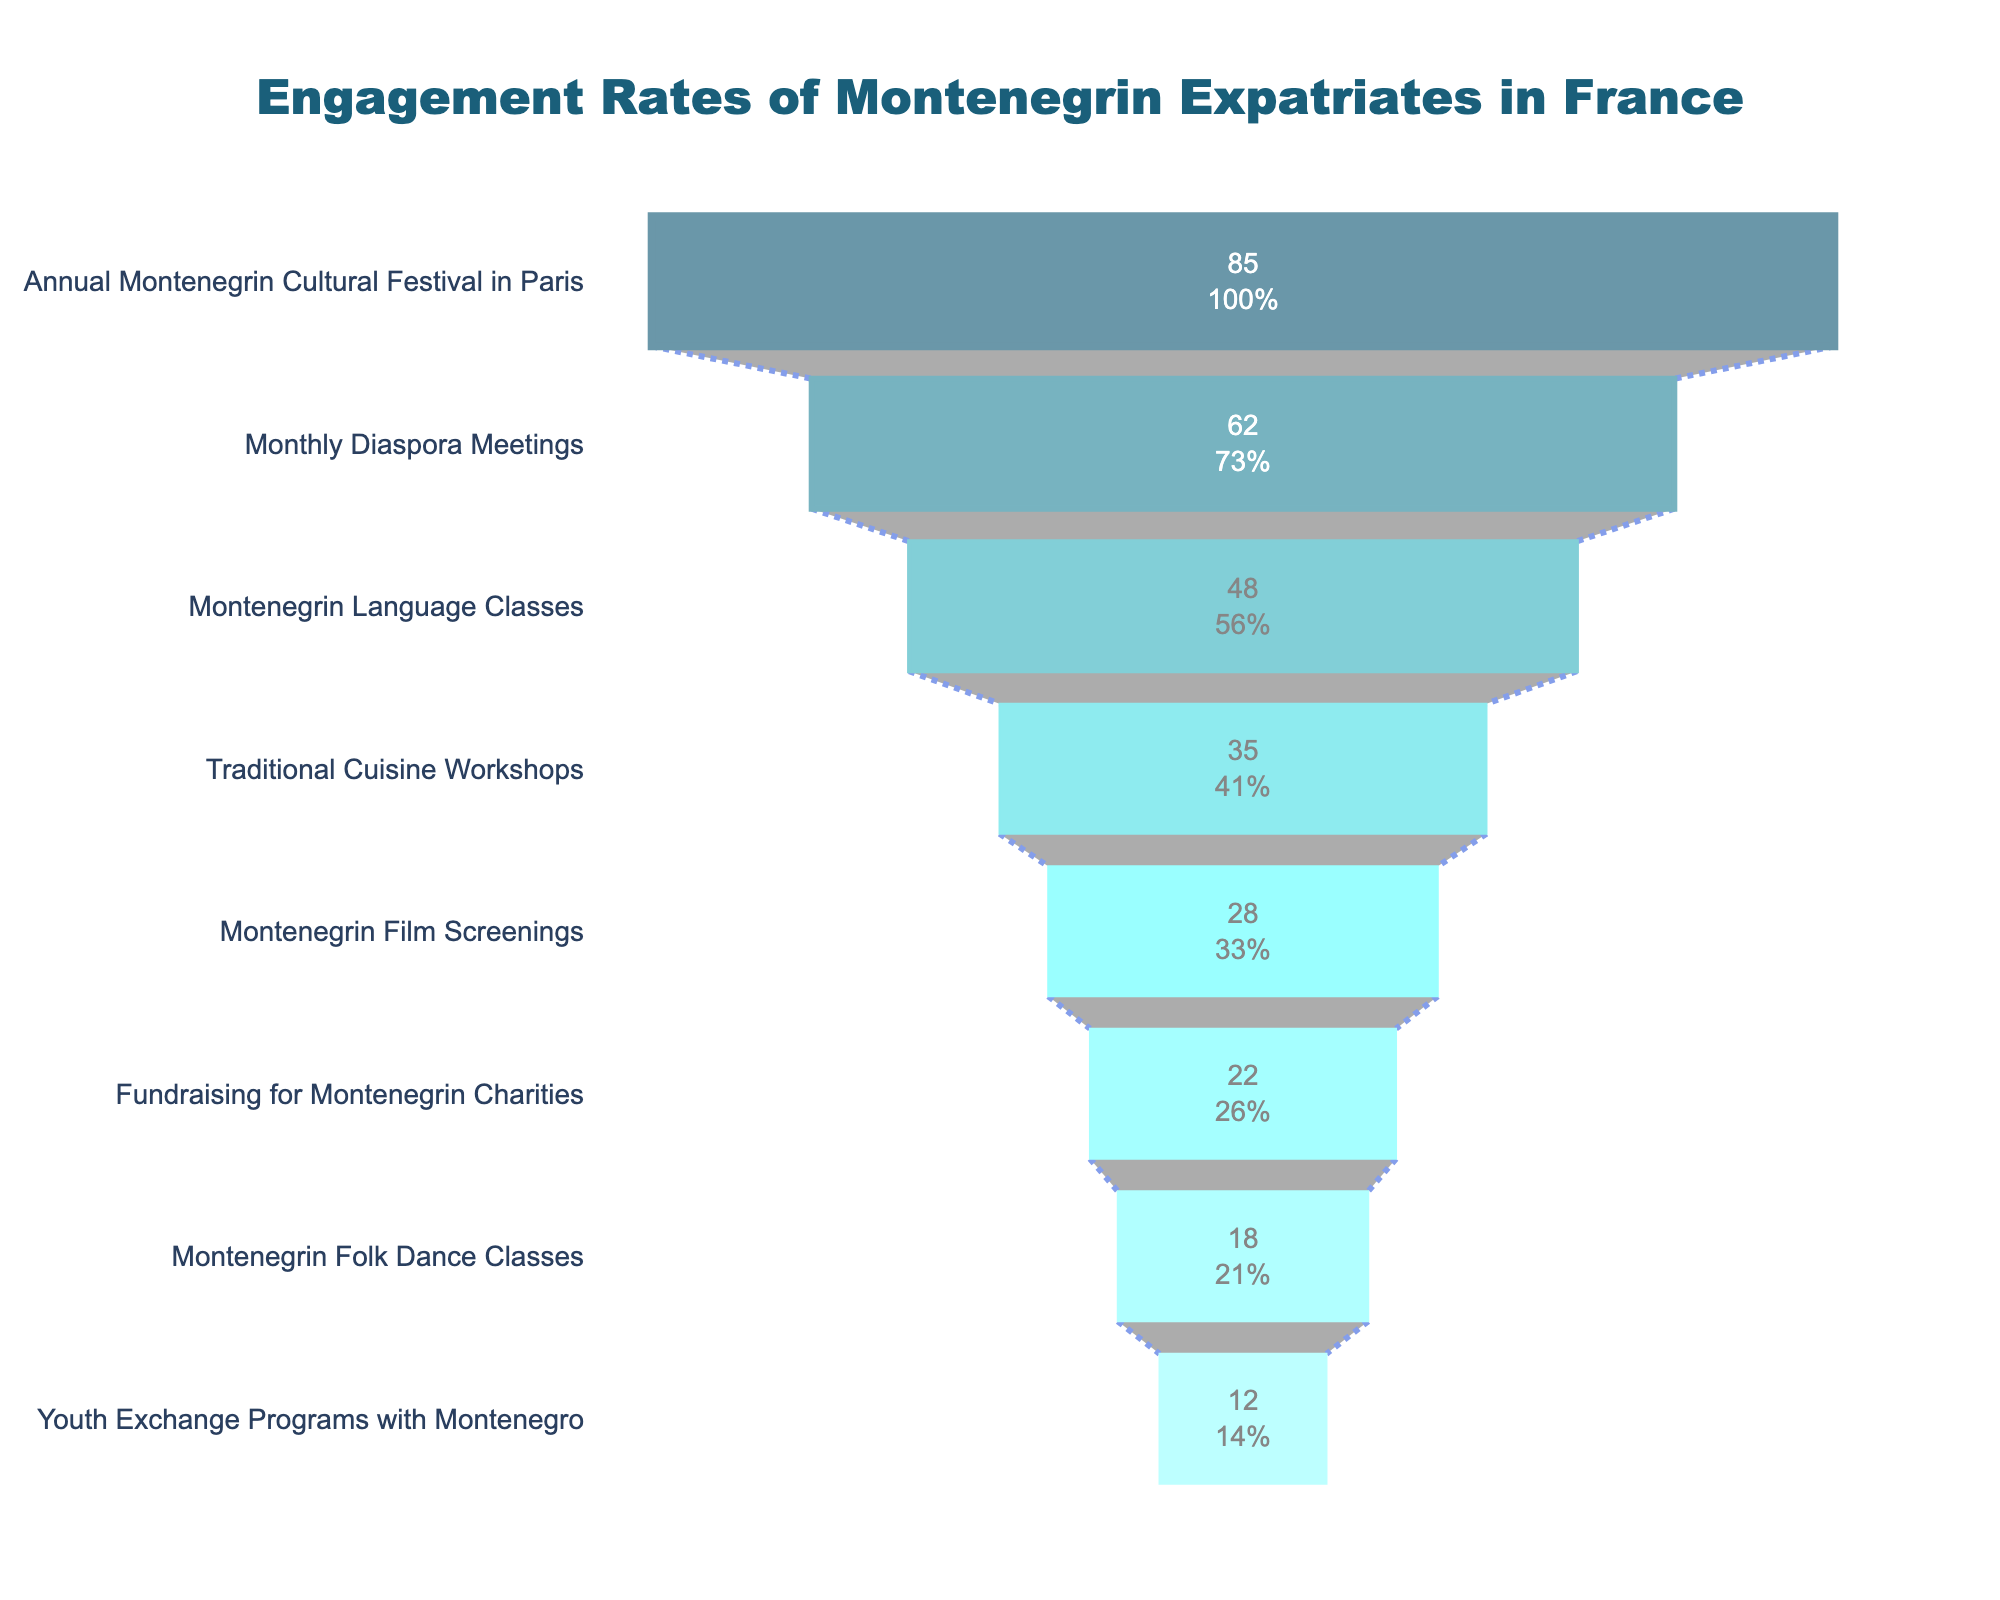How many activities are represented in the funnel chart? Count the number of unique activities listed on the funnel chart
Answer: 8 Which activity has the highest participation rate? Identify the activity with the largest value at the top of the funnel
Answer: Annual Montenegrin Cultural Festival in Paris What is the participation rate for the Montenegrin Language Classes? Locate the Montenegrin Language Classes in the funnel chart and read the participation rate
Answer: 48 How does the participation rate of Youth Exchange Programs with Montenegro compare to Montenegrin Folk Dance Classes? Compare the participation rates of Youth Exchange Programs with Montenegro and Montenegrin Folk Dance Classes
Answer: Youth Exchange Programs with Montenegro is 6% lower than Montenegrin Folk Dance Classes What is the sum of participation rates for Fundraising for Montenegrin Charities and Montenegrin Folk Dance Classes? Add the participation rates of Fundraising for Montenegrin Charities (22) and Montenegrin Folk Dance Classes (18)
Answer: 40 Which activity falls directly in the middle (median) of the participation rates? List the activities in descending order of participation rates; the median is the middle value in the ordered list
Answer: Traditional Cuisine Workshops How much higher is the participation rate for the Monthly Diaspora Meetings compared to Montenegrin Film Screenings? Subtract the participation rate of Montenegrin Film Screenings (28) from the participation rate of Monthly Diaspora Meetings (62)
Answer: 34 What percentage of the initial participants attend Montenegrin Film Screenings? Find the percentage value displayed for Montenegrin Film Screenings
Answer: 28 Which activity has the second lowest participation rate? Identify the activity just above the lowest value on the funnel chart
Answer: Youth Exchange Programs with Montenegro What is the difference between the highest and the lowest participation rates? Subtract the participation rate of Youth Exchange Programs with Montenegro (12) from the participation rate of Annual Montenegrin Cultural Festival in Paris (85)
Answer: 73 